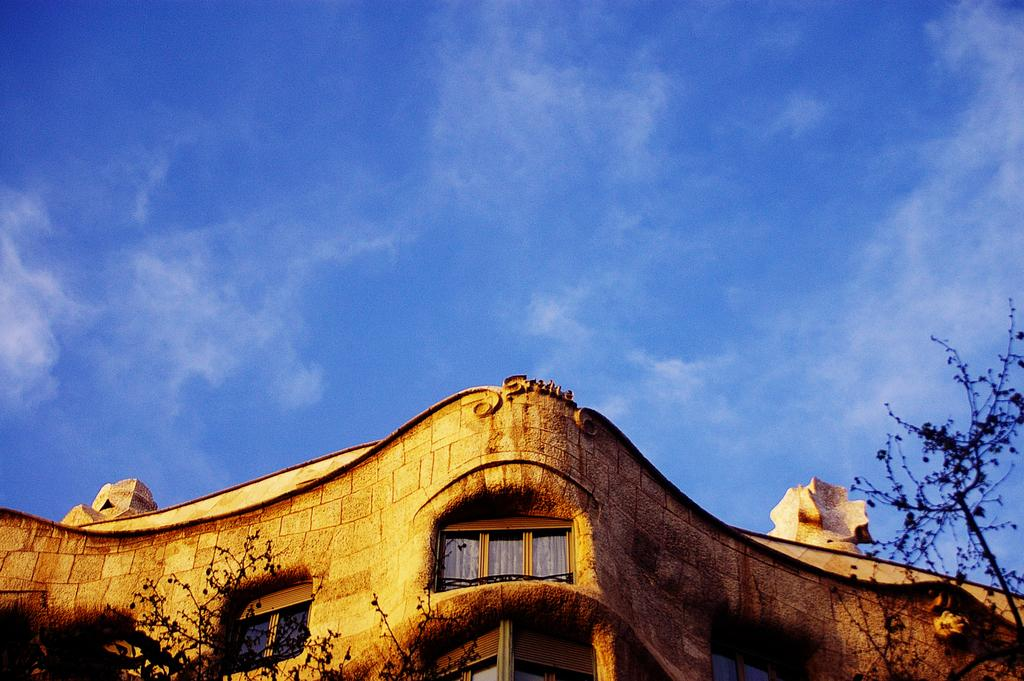What structure is located at the bottom of the image? There is a building at the bottom of the image. What feature can be seen on the building? The building has windows. What type of vegetation is at the bottom of the image? There are trees at the bottom of the image. What is visible at the top of the image? The sky is visible at the top of the image. What can be observed in the sky? Clouds are present in the sky. What type of metal is used to make the hobbies visible in the image? There is no mention of metal or hobbies in the image; it features a building, trees, and a sky with clouds. 